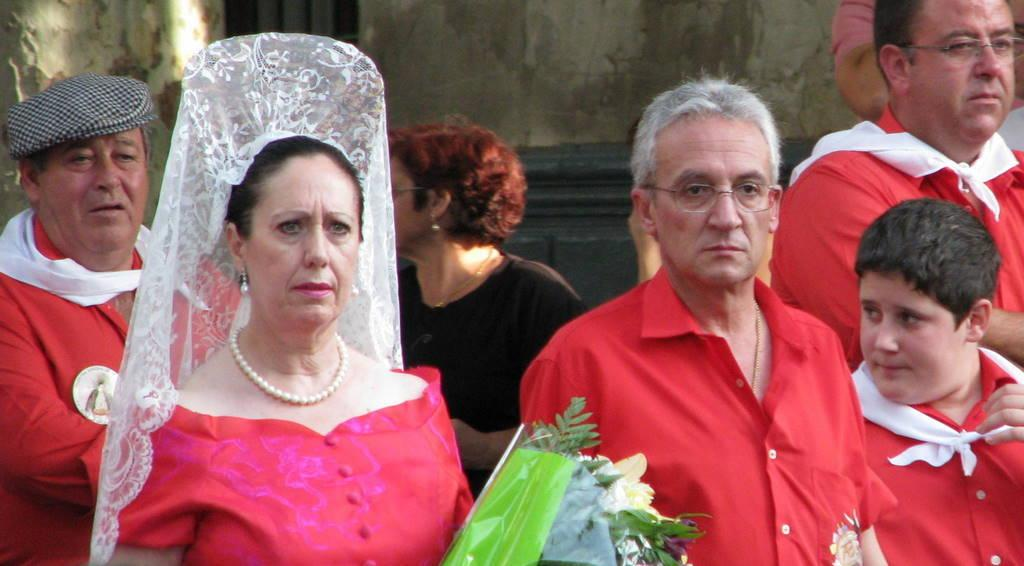How many people are in the group visible in the image? There is a group of people standing in the image, but the exact number cannot be determined from the provided facts. What can be seen besides the group of people in the image? There is a flower bouquet in the image. What is visible in the background of the image? There is a wall in the background of the image. How many kittens are sitting on the fuel tank in the image? There are no kittens or fuel tanks present in the image. Can you tell me how many people are trying to join the group in the image? The provided facts do not mention any additional people attempting to join the group in the image. 